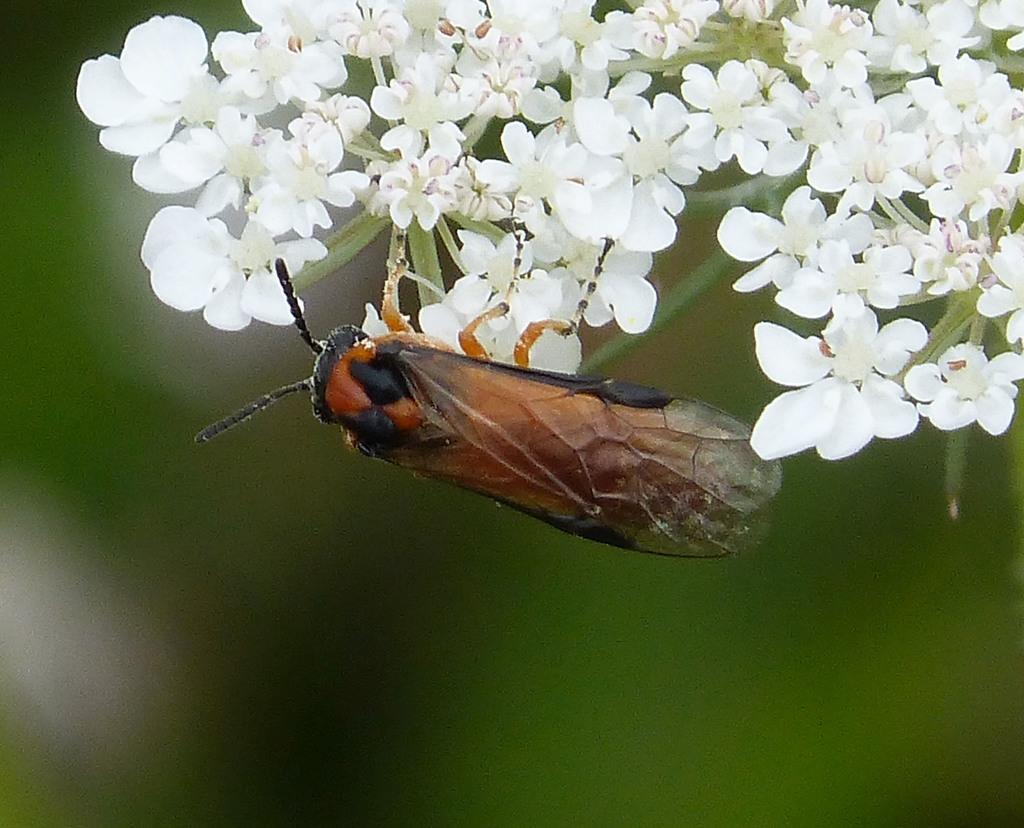What type of creature is present in the image? There is an insect in the image. What is the insect sitting on? The insect is on white flowers. Can you describe the background of the image? The background of the image is blurred. What type of marble is visible in the image? There is no marble present in the image. What type of cloth is the insect resting on? The insect is not resting on any cloth; it is on white flowers. 